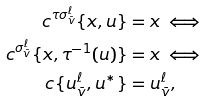<formula> <loc_0><loc_0><loc_500><loc_500>c ^ { \tau \sigma ^ { \ell } _ { \bar { v } } } \{ x , u \} & = x \iff \\ c ^ { \sigma ^ { \ell } _ { \bar { v } } } \{ x , \tau ^ { - 1 } ( u ) \} & = x \iff \\ c \{ u ^ { \ell } _ { \bar { v } } , u ^ { * } \} & = u ^ { \ell } _ { \bar { v } } ,</formula> 